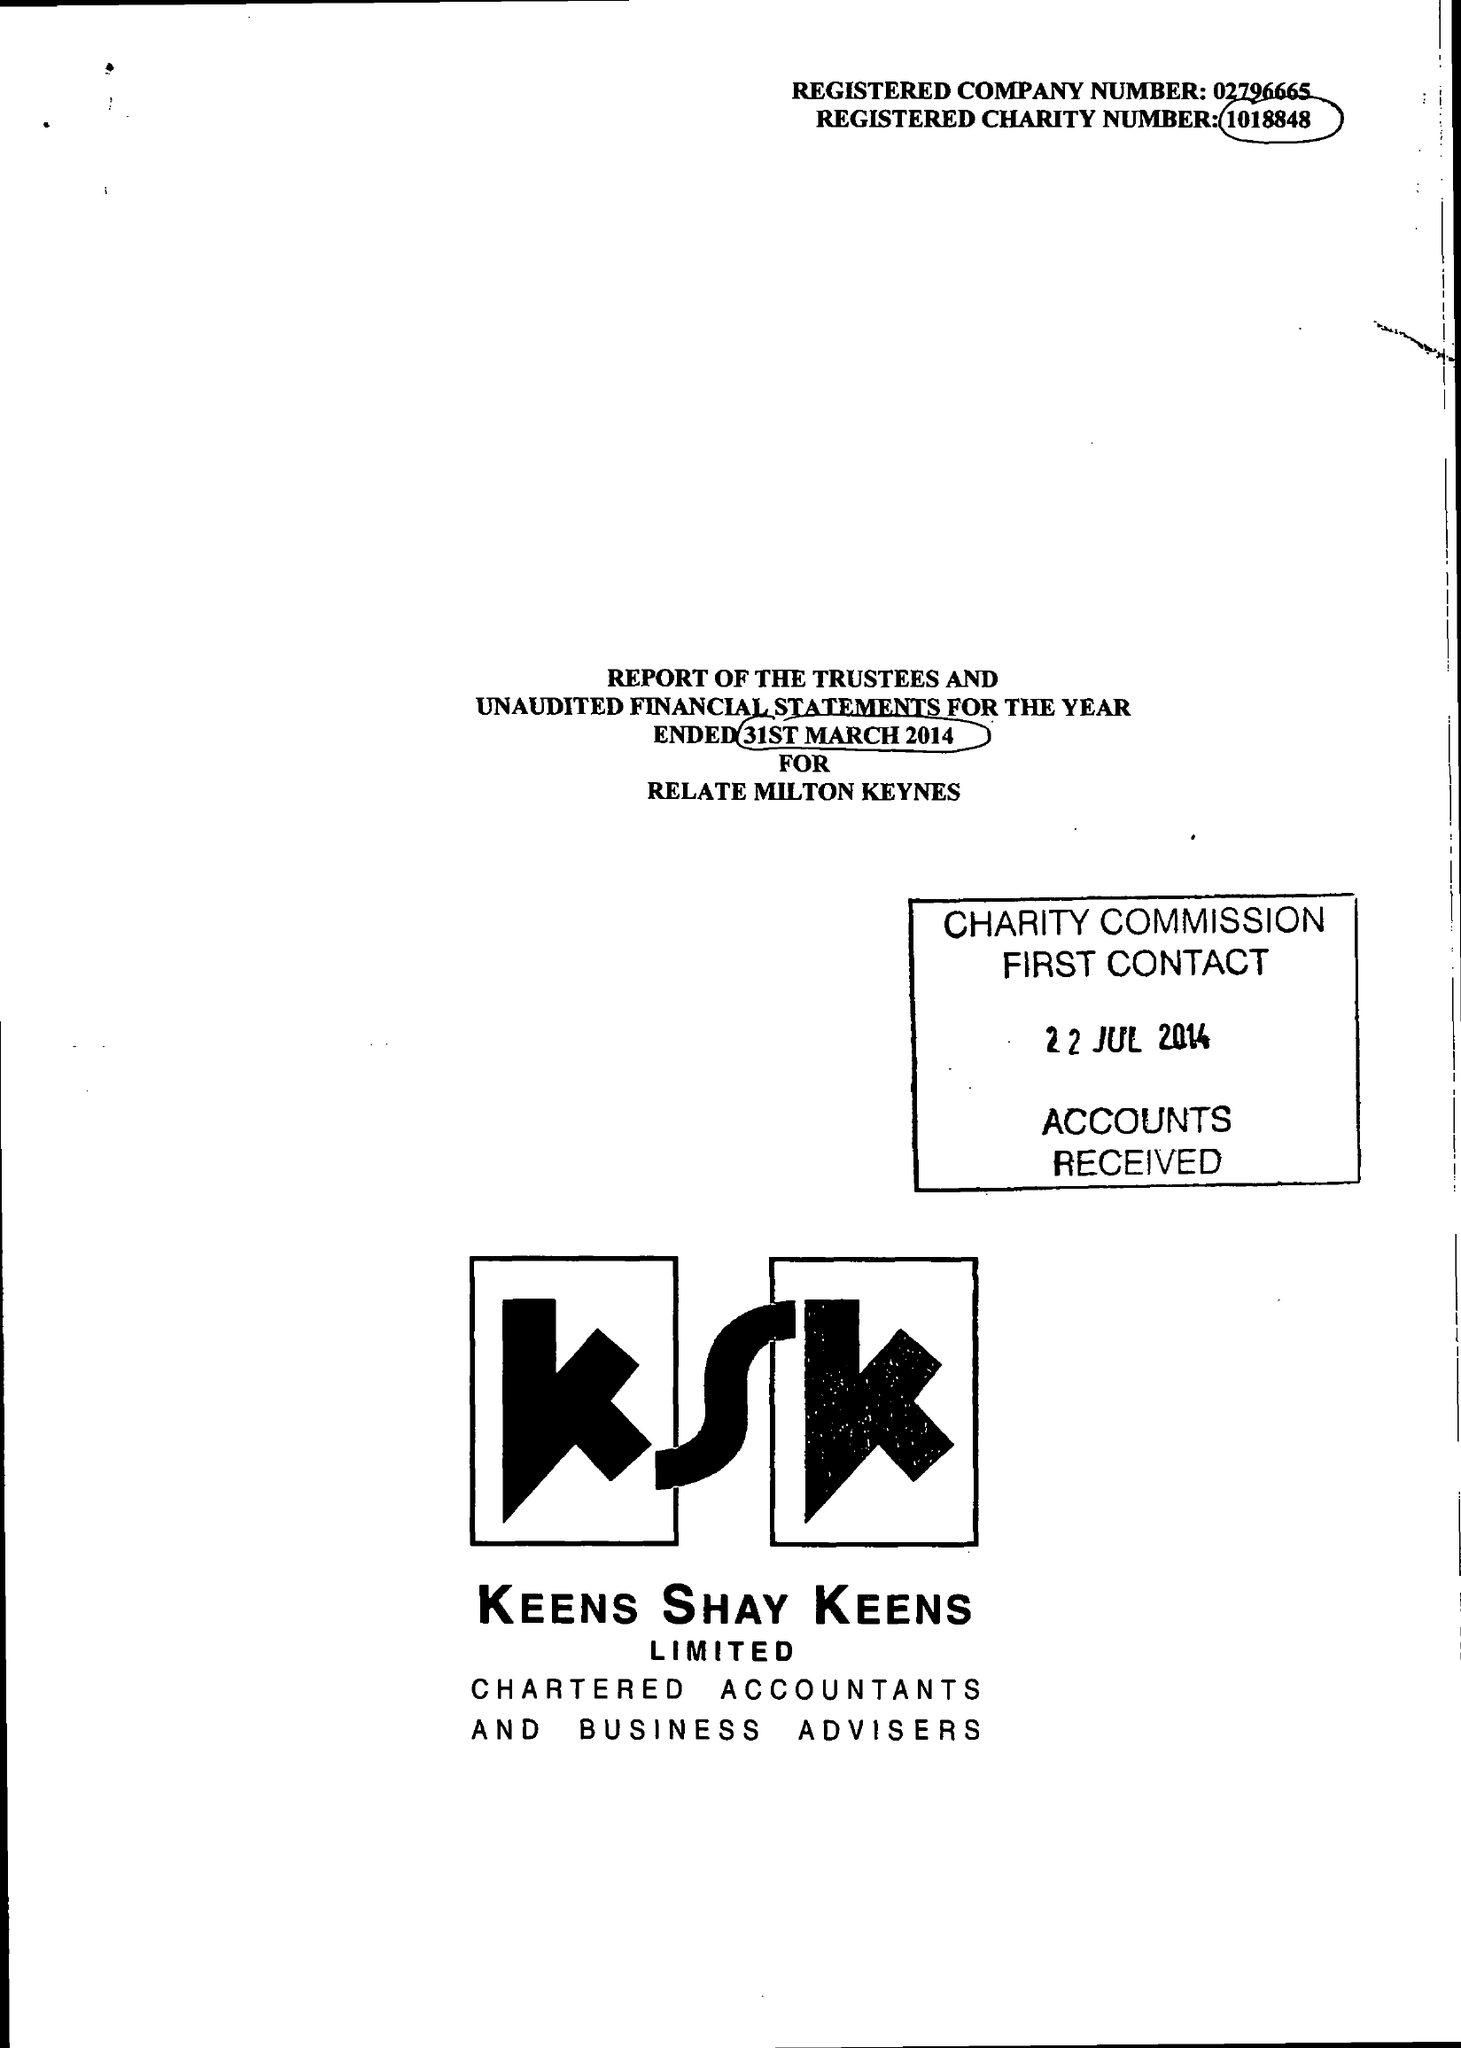What is the value for the charity_number?
Answer the question using a single word or phrase. 1018848 